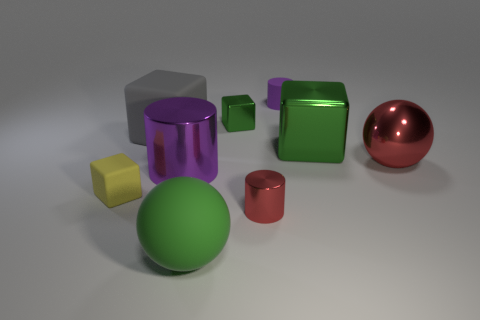How many other things are there of the same color as the metal sphere?
Offer a terse response. 1. There is another purple thing that is the same shape as the small purple thing; what is it made of?
Your answer should be compact. Metal. Is the number of green rubber balls behind the green rubber thing greater than the number of large green metal cubes?
Give a very brief answer. No. Are there any tiny metallic cylinders of the same color as the big metallic cylinder?
Keep it short and to the point. No. The purple rubber cylinder has what size?
Offer a terse response. Small. Is the color of the big metallic sphere the same as the small rubber block?
Offer a terse response. No. What number of objects are big gray objects or cubes to the right of the small matte cylinder?
Keep it short and to the point. 2. There is a small cylinder behind the tiny object that is left of the purple shiny object; how many yellow objects are in front of it?
Give a very brief answer. 1. What material is the large block that is the same color as the large rubber ball?
Keep it short and to the point. Metal. What number of red objects are there?
Your answer should be very brief. 2. 